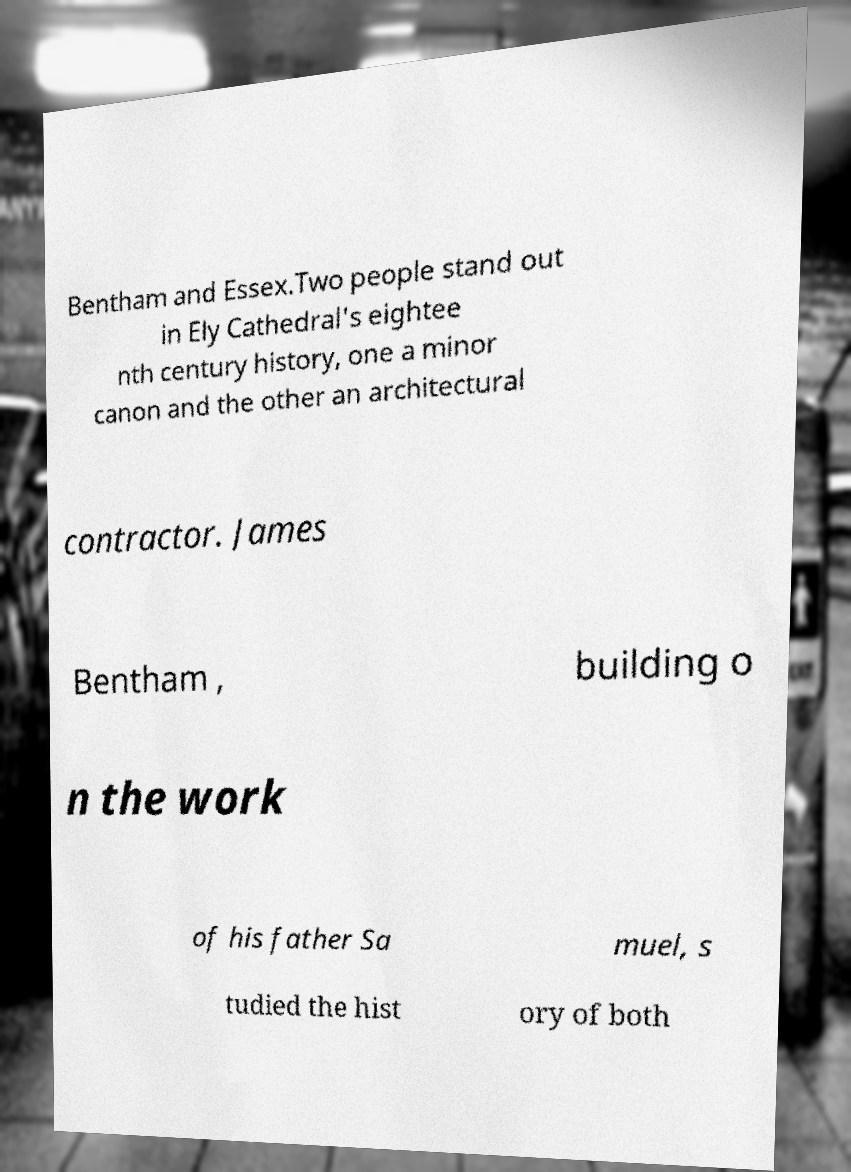For documentation purposes, I need the text within this image transcribed. Could you provide that? Bentham and Essex.Two people stand out in Ely Cathedral's eightee nth century history, one a minor canon and the other an architectural contractor. James Bentham , building o n the work of his father Sa muel, s tudied the hist ory of both 